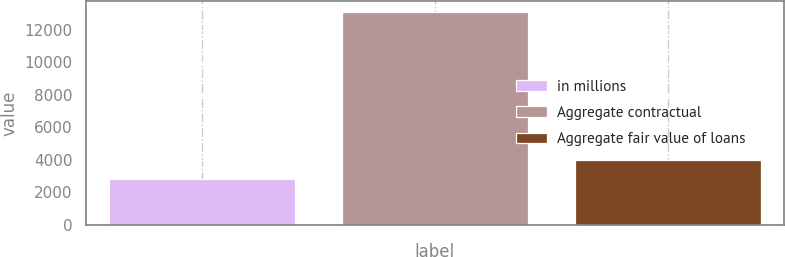<chart> <loc_0><loc_0><loc_500><loc_500><bar_chart><fcel>in millions<fcel>Aggregate contractual<fcel>Aggregate fair value of loans<nl><fcel>2839.7<fcel>13106<fcel>3980.4<nl></chart> 